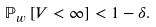Convert formula to latex. <formula><loc_0><loc_0><loc_500><loc_500>{ \mathbb { P } } _ { w } \left [ V < \infty \right ] < 1 - \delta .</formula> 